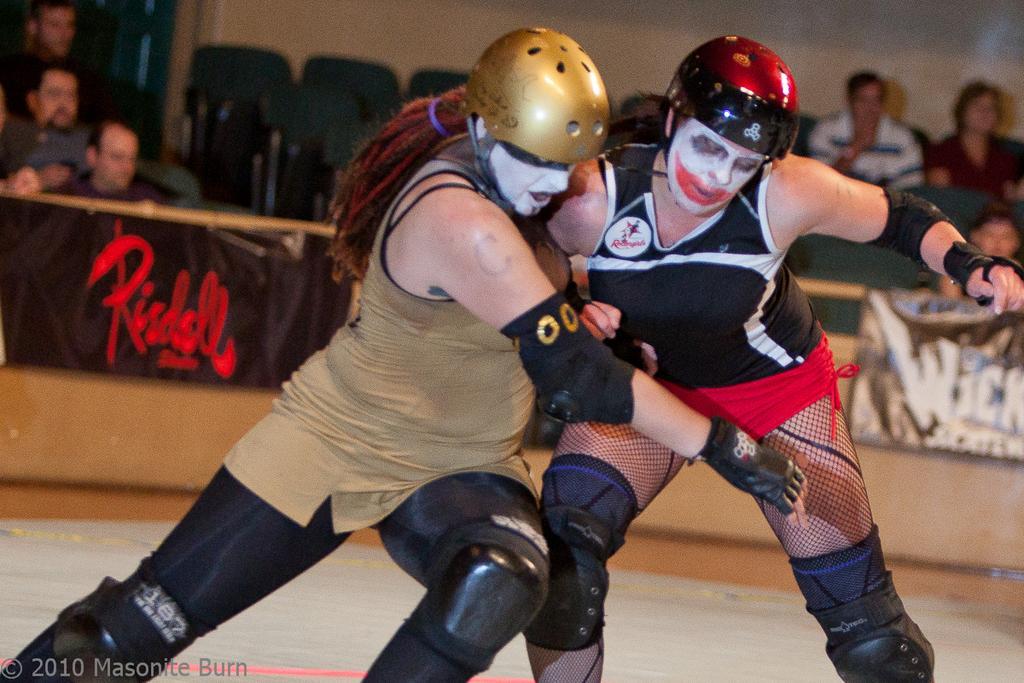Please provide a concise description of this image. There are two women in different color dresses fighting with each other on a stage. In the left bottom corner, there is a watermark. In the background, there are banners attached to the thread and there is wall. 